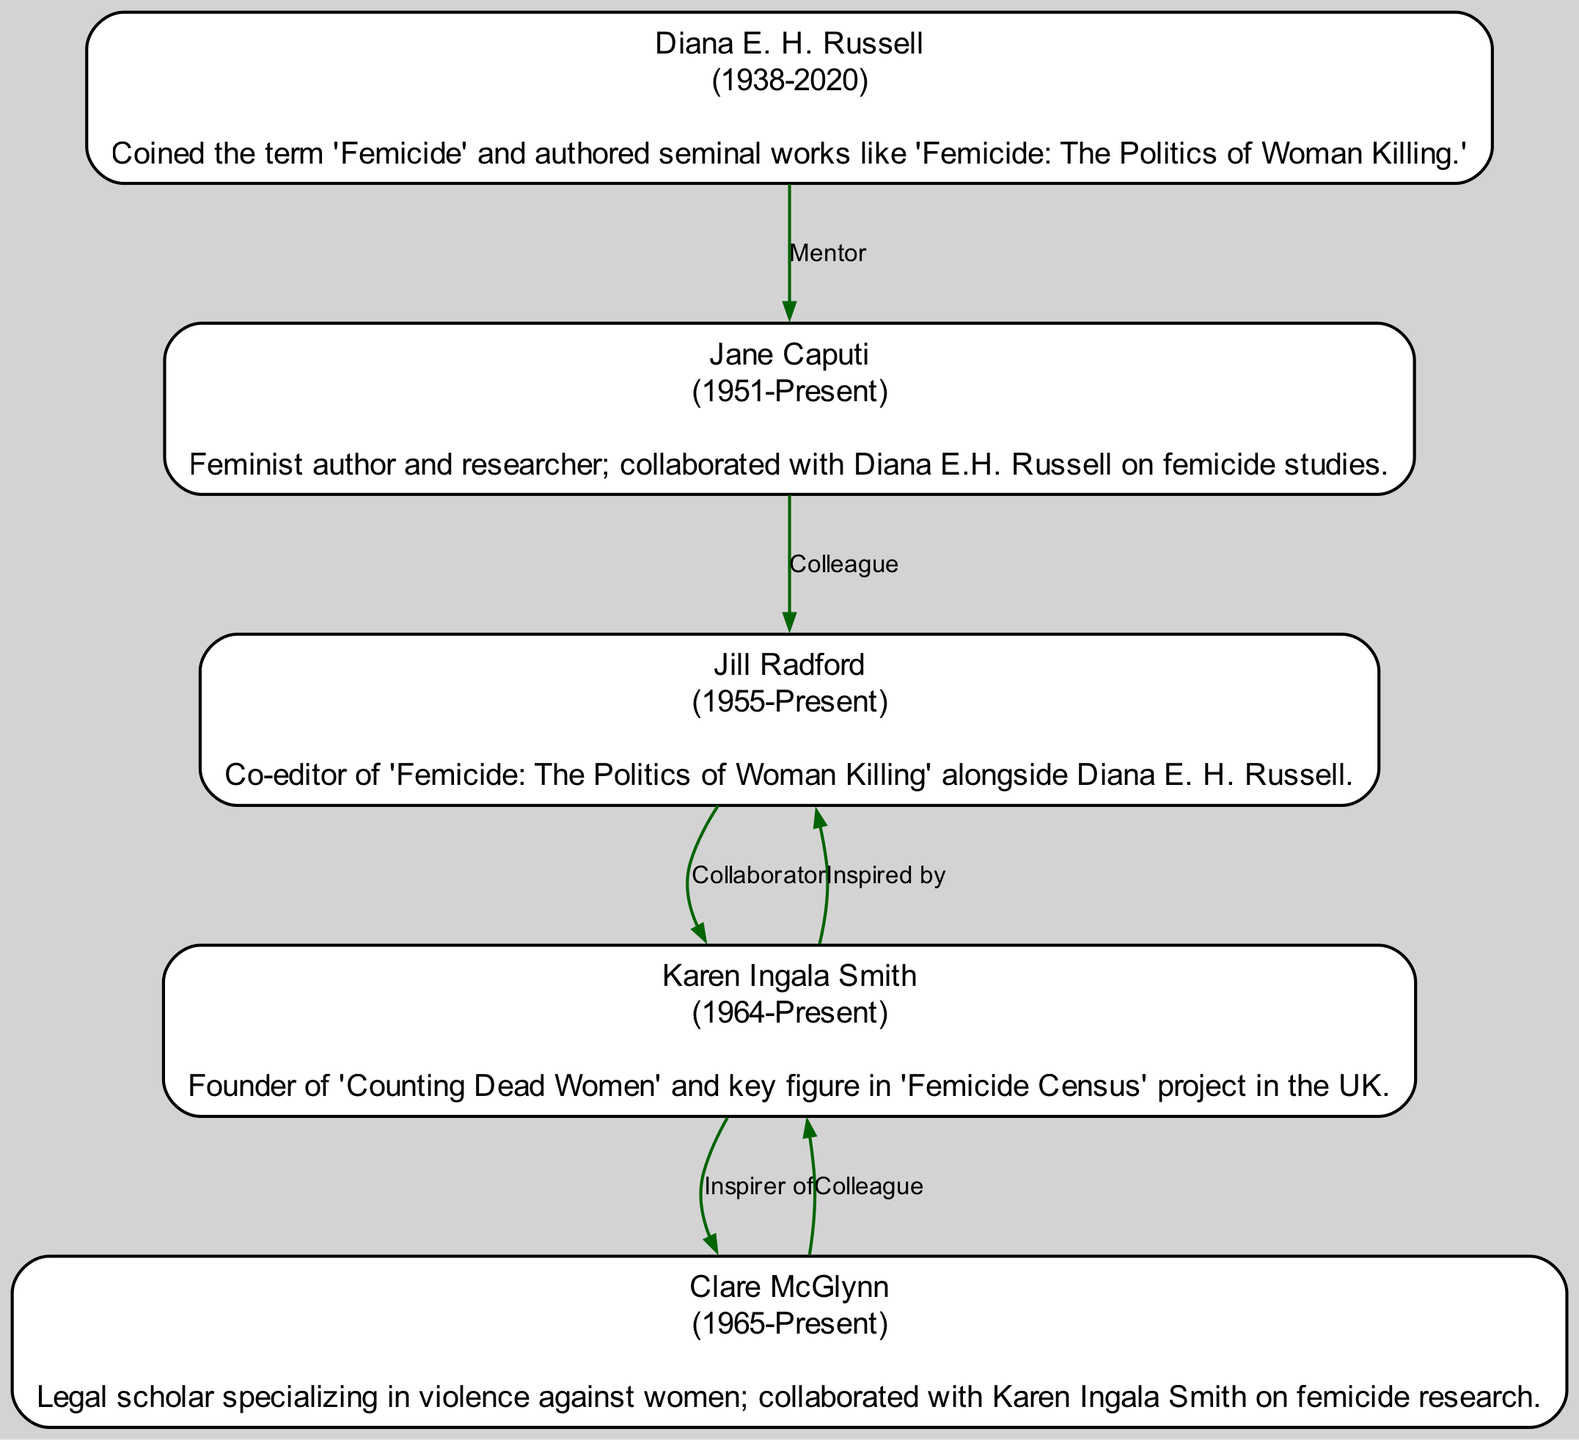What is the contribution of Diana E. H. Russell? The diagram states that Diana E. H. Russell coined the term 'Femicide' and authored seminal works like 'Femicide: The Politics of Woman Killing.'
Answer: Coined the term 'Femicide' and authored seminal works like 'Femicide: The Politics of Woman Killing.' Who is Jane Caputi's mentor? According to the connections listed in the diagram, Jane Caputi's mentor is Diana E. H. Russell.
Answer: Diana E. H. Russell How many individuals are mentioned in the diagram? By counting each unique name listed in the diagram, we find that there are five individuals shown.
Answer: 5 What relation does Karen Ingala Smith have with Jill Radford? The diagram specifies that Karen Ingala Smith is a collaborator of Jill Radford, indicating a partnership in their work related to femicide.
Answer: Collaborator Which year was Karen Ingala Smith born? The diagram lists the birth year of Karen Ingala Smith as 1964, making it clear when she was born.
Answer: 1964 Who did Clare McGlynn collaborate with? The diagram indicates that Clare McGlynn collaborated with Karen Ingala Smith, providing a direct connection between the two advocates in their research efforts.
Answer: Karen Ingala Smith What is the relationship type between Jill Radford and Jane Caputi? From the connections in the diagram, we see that Jill Radford is a colleague of Jane Caputi, highlighting their professional relationship.
Answer: Colleague Which individual is inspired by Jill Radford? The diagram states that Karen Ingala Smith is inspired by Jill Radford, demonstrating the impact of Radford's work on Smith's initiatives.
Answer: Karen Ingala Smith What notable project is Karen Ingala Smith associated with? The diagram specifies that Karen Ingala Smith is the founder of 'Counting Dead Women' and is a key figure in the 'Femicide Census' project in the UK, clearly indicating her involvement in these initiatives.
Answer: Counting Dead Women and Femicide Census 